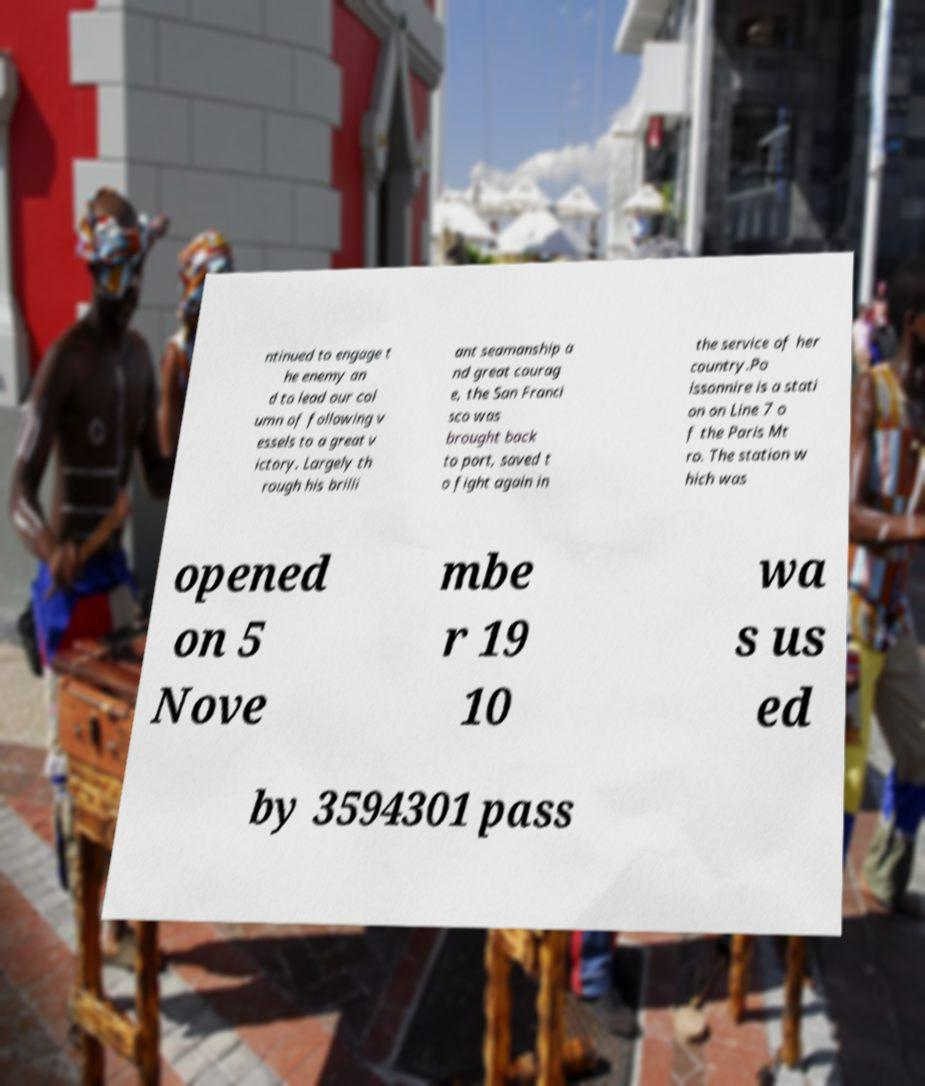For documentation purposes, I need the text within this image transcribed. Could you provide that? ntinued to engage t he enemy an d to lead our col umn of following v essels to a great v ictory. Largely th rough his brilli ant seamanship a nd great courag e, the San Franci sco was brought back to port, saved t o fight again in the service of her country.Po issonnire is a stati on on Line 7 o f the Paris Mt ro. The station w hich was opened on 5 Nove mbe r 19 10 wa s us ed by 3594301 pass 